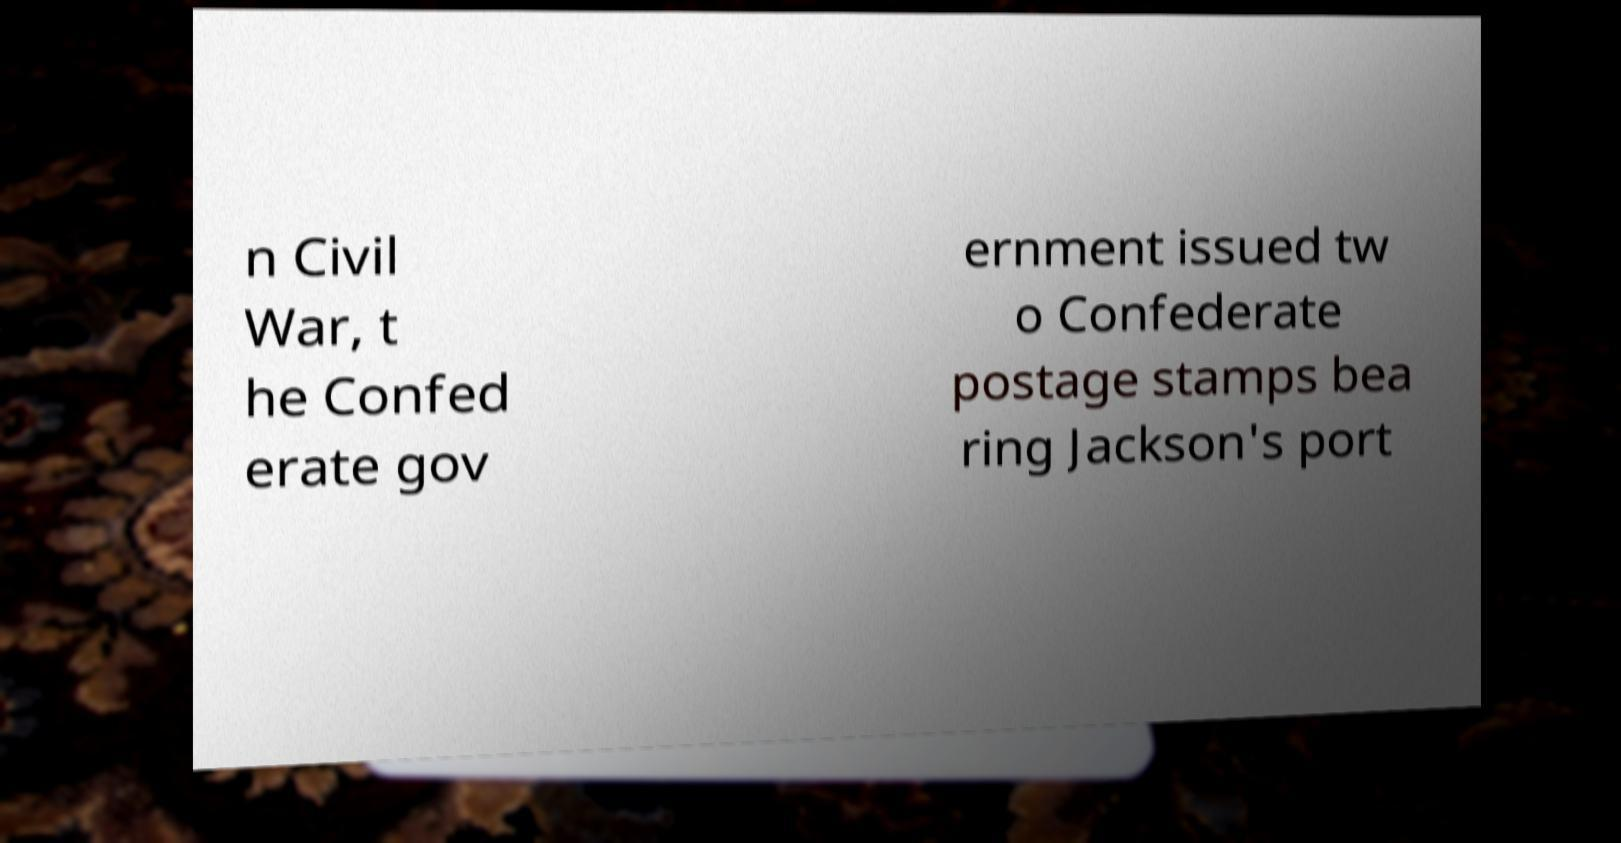For documentation purposes, I need the text within this image transcribed. Could you provide that? n Civil War, t he Confed erate gov ernment issued tw o Confederate postage stamps bea ring Jackson's port 